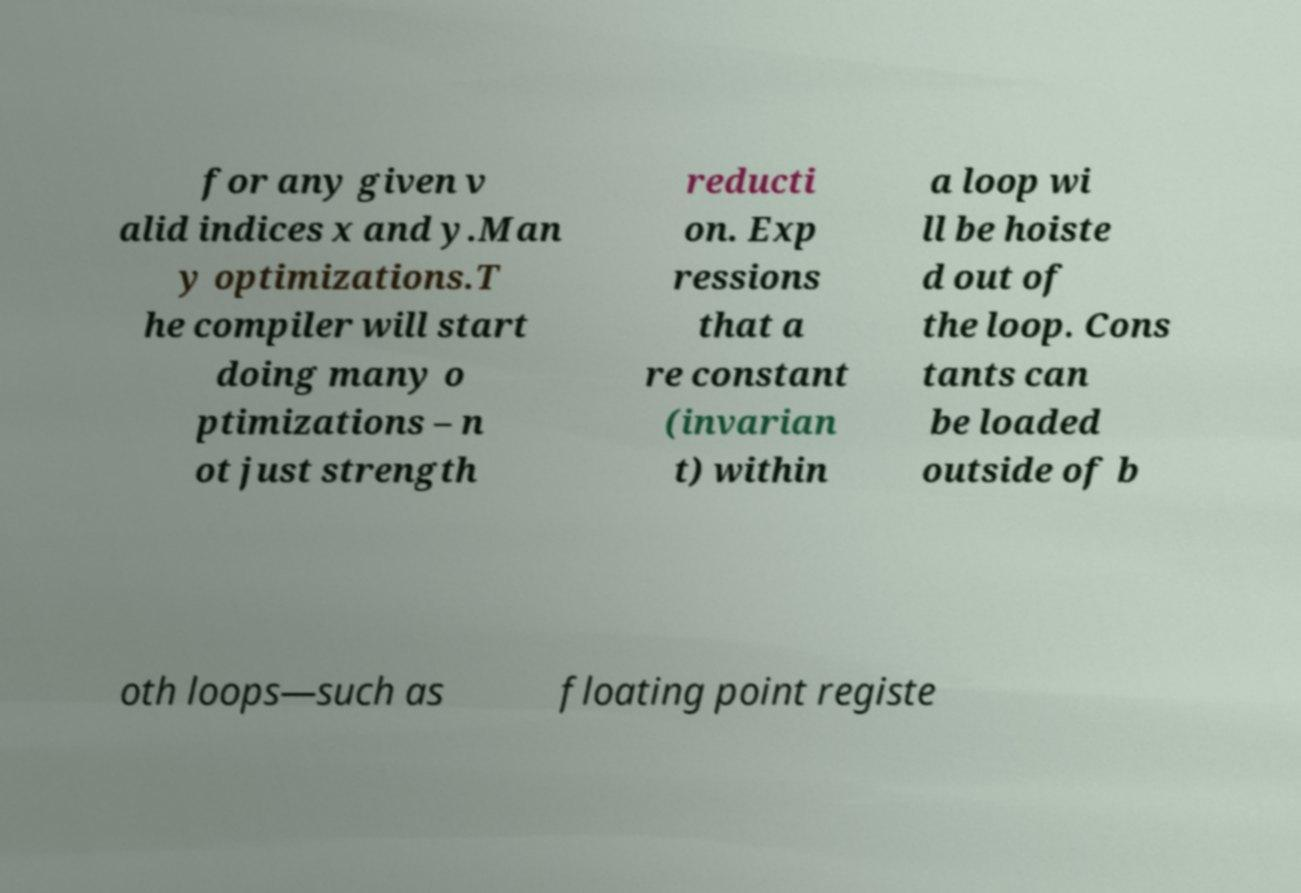Could you assist in decoding the text presented in this image and type it out clearly? for any given v alid indices x and y.Man y optimizations.T he compiler will start doing many o ptimizations – n ot just strength reducti on. Exp ressions that a re constant (invarian t) within a loop wi ll be hoiste d out of the loop. Cons tants can be loaded outside of b oth loops—such as floating point registe 